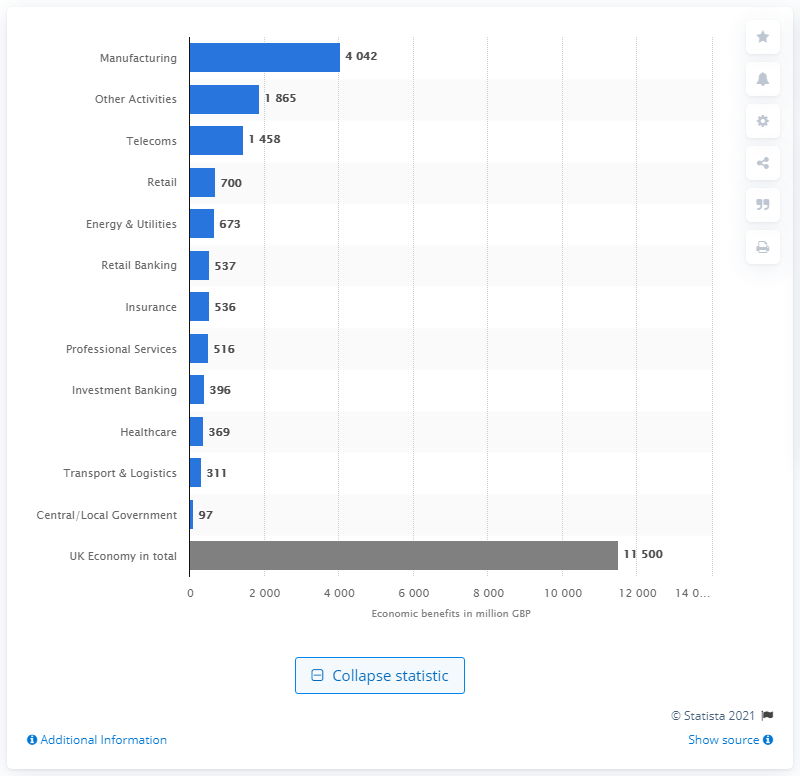Point out several critical features in this image. The telecom industry received $145.8 billion in benefits from the Internet of Things (IoT) in the given year. 